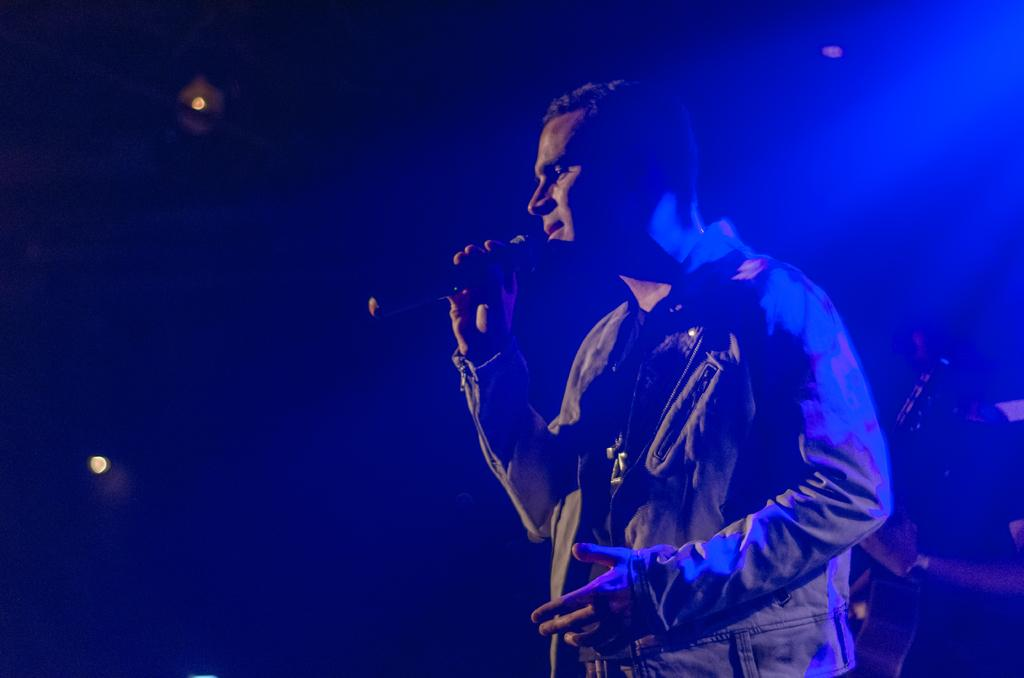How many people are in the image? There are two persons standing in the image. What are the people holding in the image? One person is holding a microphone, and the other person is holding a guitar. What can be seen in the image that provides illumination? There are lights visible in the image. What is the color of the background in the image? The background of the image is dark. What type of dinner is being served in the image? There is no dinner present in the image; it features two people holding a microphone and a guitar. Can you tell me where the garden is located in the image? There is no garden present in the image. 